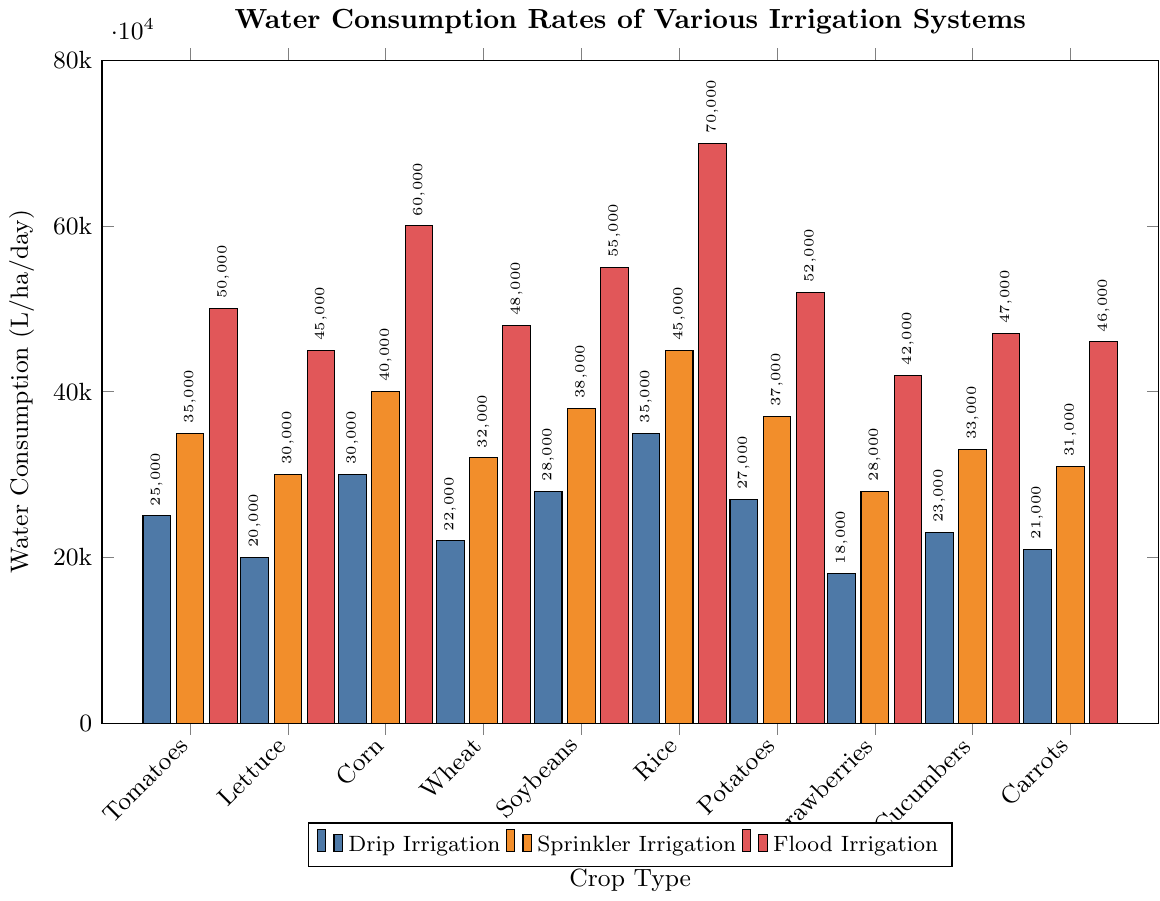What is the water consumption rate for drip irrigation for rice? Look for the bar corresponding to rice under the "Drip Irrigation" category. The height of the bar indicates the water consumption rate in liters per hectare per day. It reads 35000 L/ha/day
Answer: 35000 L/ha/day Which crop uses the least water under flood irrigation? Compare the heights of the bars under the "Flood Irrigation" category for all crops. The shortest bar corresponds to strawberries, indicating the least water usage.
Answer: Strawberries How much more water does sprinkler irrigation use for tomatoes compared to strawberries? Find the heights of the bars for tomatoes and strawberries under "Sprinkler Irrigation". For tomatoes, it's 35000 L/ha/day, and for strawberries, it's 28000 L/ha/day. Subtract the latter from the former: 35000 - 28000 = 7000
Answer: 7000 L/ha/day Which irrigation system uses the most water for cucumbers, and how much is it? Look at the three bars for cucumbers. The tallest bar corresponds to "Flood Irrigation" and it reads 47000 L/ha/day.
Answer: Flood Irrigation, 47000 L/ha/day What is the average water consumption of wheat under all three irrigation systems? Find the heights of the bars for wheat under all three systems: 22000, 32000, and 48000 L/ha/day. Calculate the average: (22000 + 32000 + 48000) / 3 = 34000
Answer: 34000 L/ha/day Which crop uses the most water under sprinkler irrigation? Compare the heights of the bars under the "Sprinkler Irrigation" category for all crops. The tallest bar corresponds to rice.
Answer: Rice How much more water does flood irrigation use for corn compared to drip irrigation? Find the heights of the bars for corn under both "Flood Irrigation" and "Drip Irrigation". For flood irrigation, it's 60000 L/ha/day and for drip irrigation, it's 30000 L/ha/day. Subtract the latter from the former: 60000 - 30000 = 30000
Answer: 30000 L/ha/day Which irrigation system uses the least water overall, and for which crop is it used? Look for the shortest bar in the entire chart. It is under "Drip Irrigation" for strawberries, reading 18000 L/ha/day.
Answer: Drip Irrigation for strawberries What is the total water consumption for rice under all irrigation systems? Find the heights of the bars for rice under all three systems: 35000, 45000, and 70000 L/ha/day. Sum these values: 35000 + 45000 + 70000 = 150000
Answer: 150000 L/ha/day 